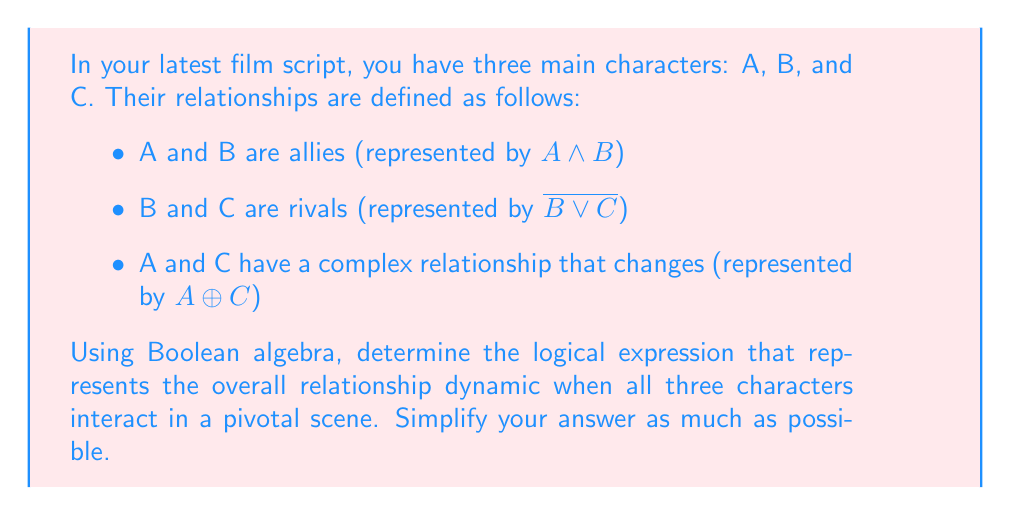What is the answer to this math problem? Let's approach this step-by-step:

1) We need to combine the three given relationships using the AND operator, as all these relationships exist simultaneously in the scene:

   $$(A \land B) \land (\overline{B \lor C}) \land (A \oplus C)$$

2) Let's focus on simplifying $\overline{B \lor C}$ first. Using De Morgan's Law:

   $\overline{B \lor C} = \overline{B} \land \overline{C}$

3) Now our expression looks like this:

   $$(A \land B) \land (\overline{B} \land \overline{C}) \land (A \oplus C)$$

4) Rearranging the terms (associative property of AND):

   $$A \land B \land \overline{B} \land \overline{C} \land (A \oplus C)$$

5) Note that $B \land \overline{B} = 0$ (contradiction). This means the entire expression will evaluate to 0, regardless of the values of A and C.

6) Therefore, the simplified expression is just:

   $$0$$

This result suggests that the given set of relationships creates a logical impossibility, which could be an interesting plot point in your script. It implies that these exact relationships cannot coexist in a single scene, potentially creating dramatic tension or necessitating character development.
Answer: $$0$$ 